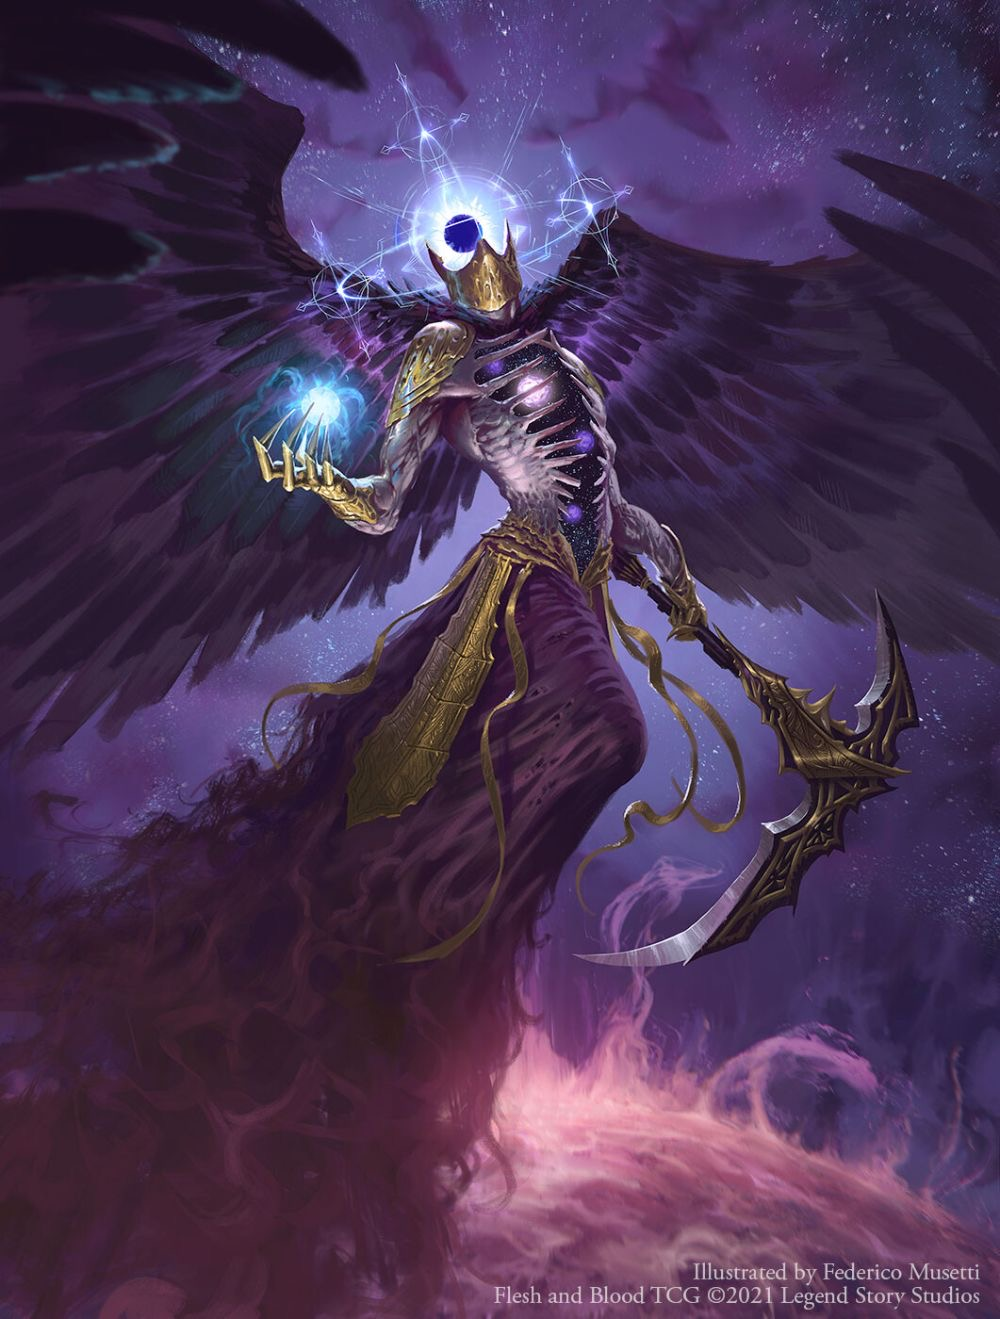go into deep detail with this image, analyze each small detail in this image as well even things that aren’t in your normal data This is an image of a creature known as the "Reaper King". It is a skeletal figure with large, black wings and a glowing blue eye in the center of its chest. It is holding a large scythe in its right hand and a small, glowing orb in its left hand. It is standing in a dark, purple void with a starry background.

The Reaper King is a powerful and feared creature. It is said to be the ruler of the underworld and the bringer of death. It is also said to be the guardian of the souls of the dead.

The Reaper King is a complex and fascinating creature. It is a symbol of death, but it is also a symbol of hope. It is a reminder that even in the darkest of times, there is always light. 